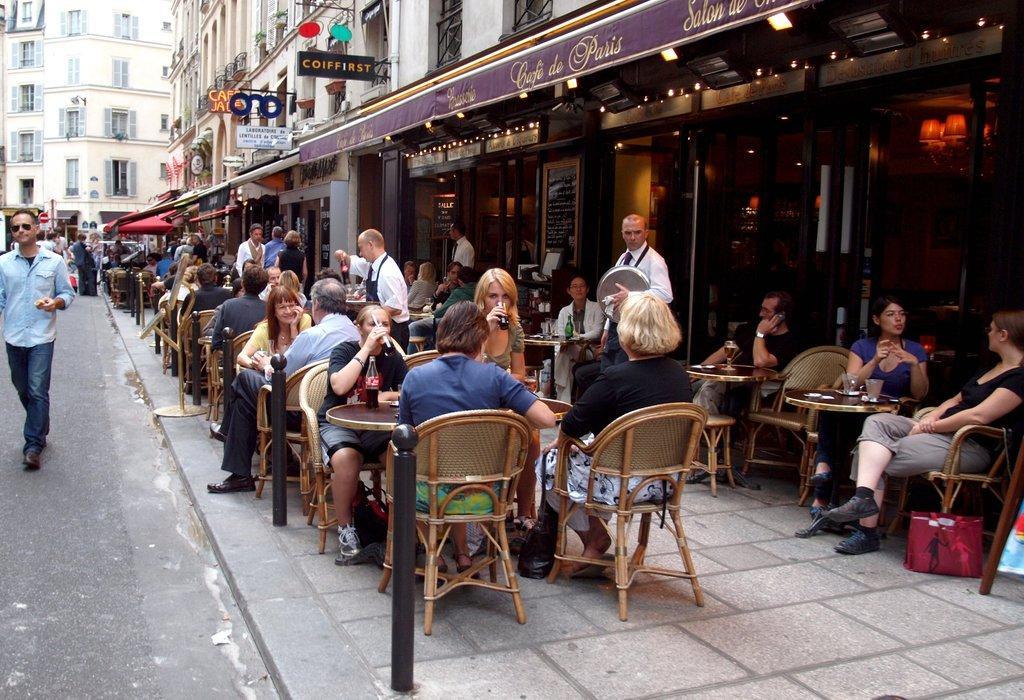Please provide a concise description of this image. As we can see in the image there are buildings, chairs, tables and few people here and there. 